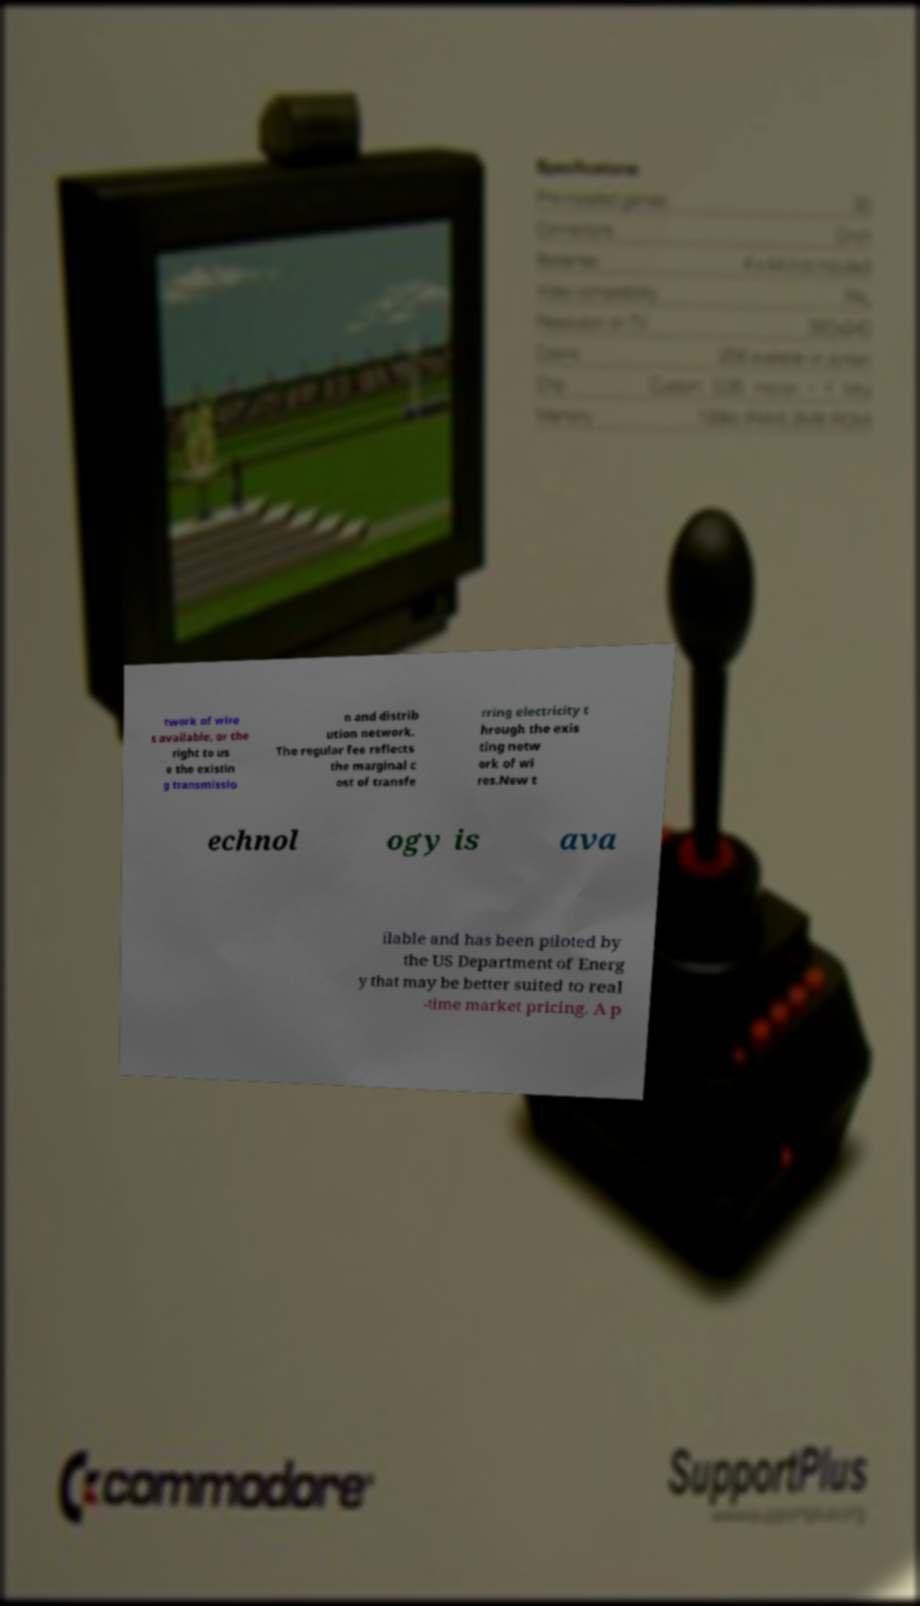Can you accurately transcribe the text from the provided image for me? twork of wire s available, or the right to us e the existin g transmissio n and distrib ution network. The regular fee reflects the marginal c ost of transfe rring electricity t hrough the exis ting netw ork of wi res.New t echnol ogy is ava ilable and has been piloted by the US Department of Energ y that may be better suited to real -time market pricing. A p 